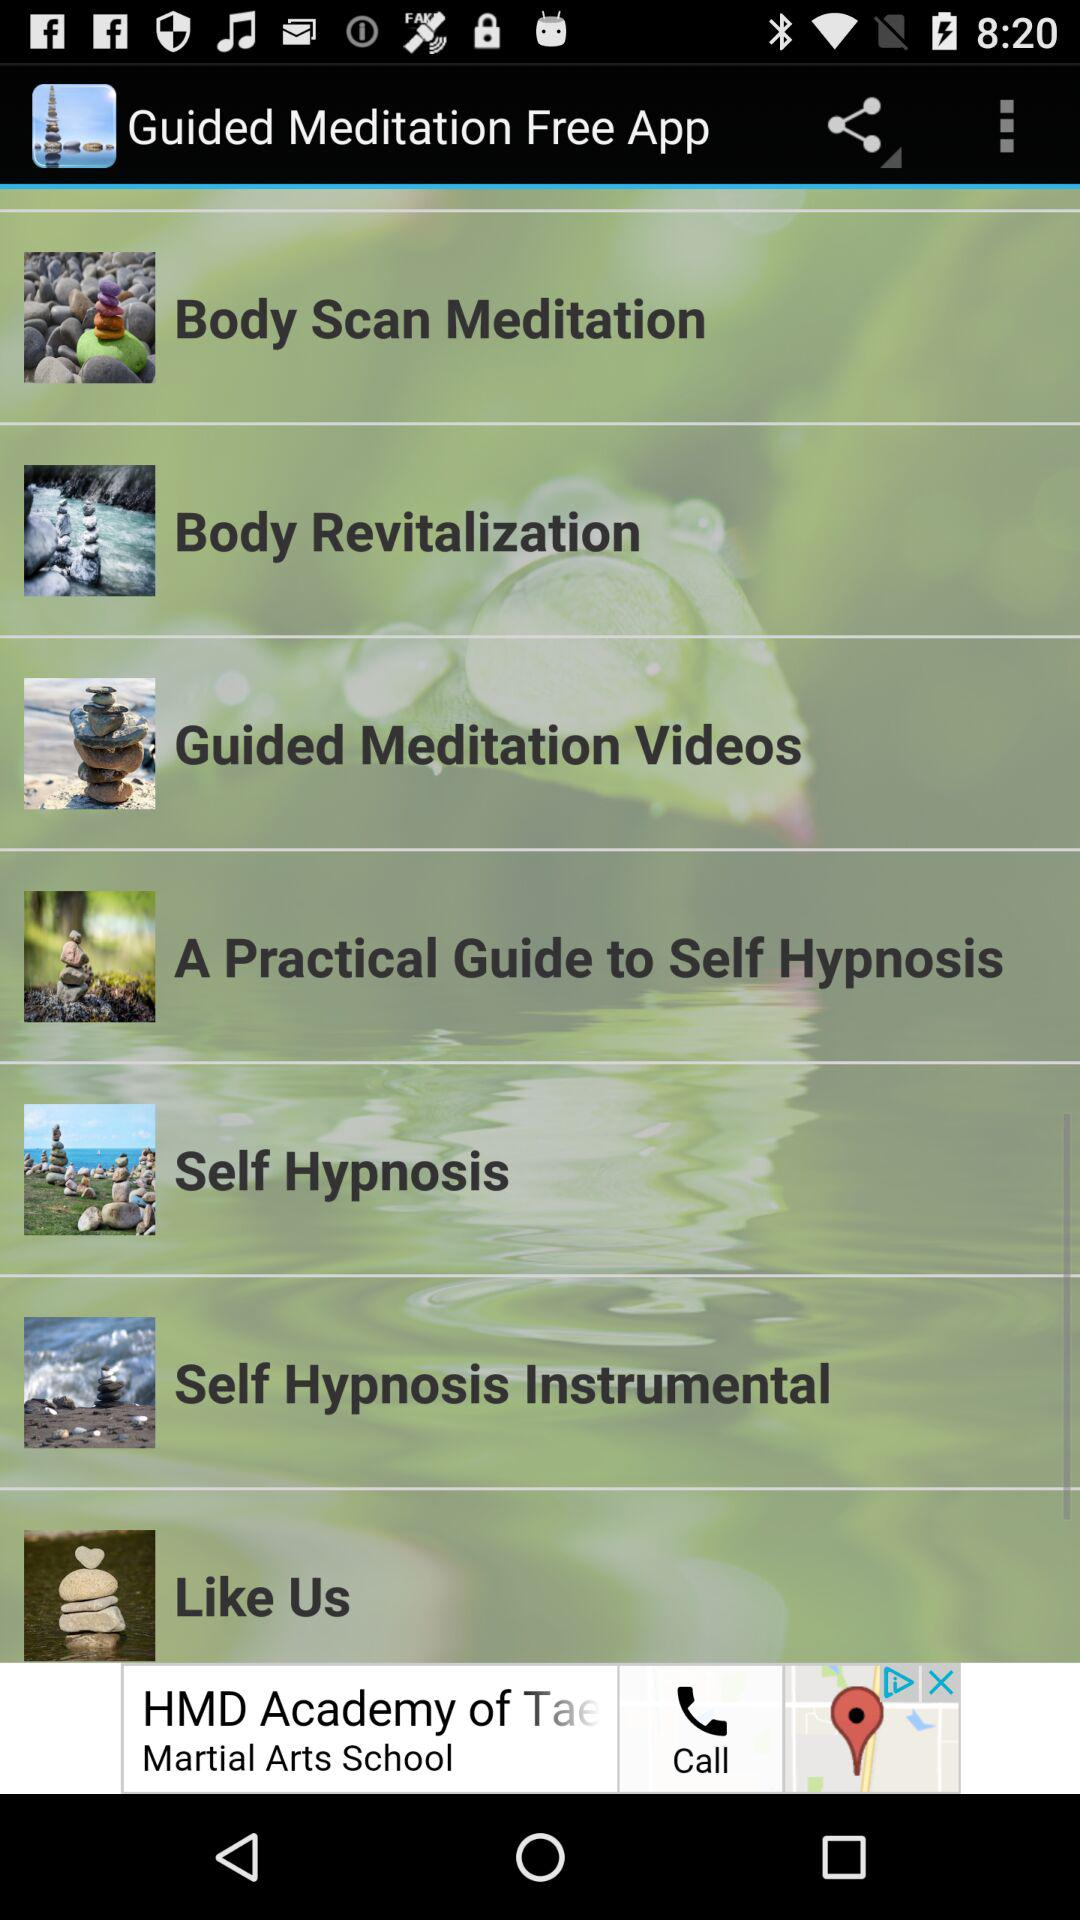What is the name of the application? The application name is "Guided Meditation Free App". 